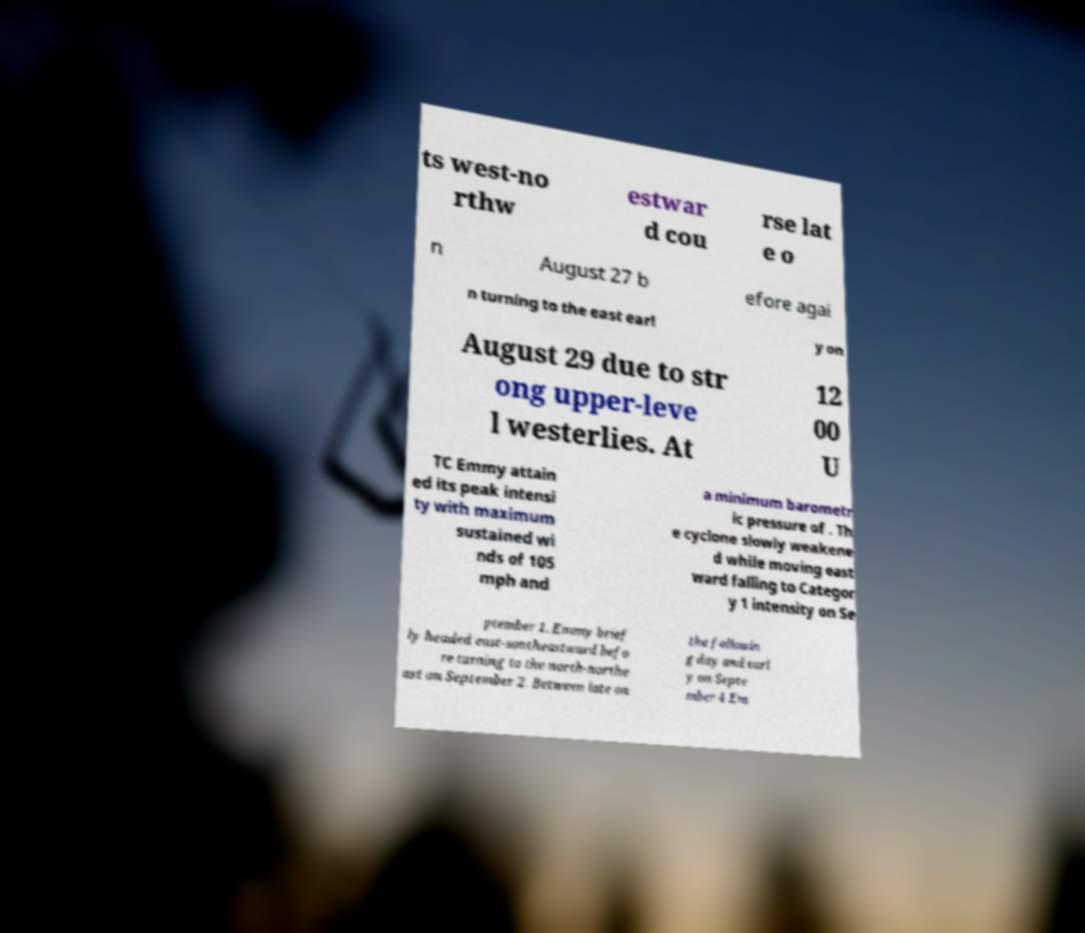Can you read and provide the text displayed in the image?This photo seems to have some interesting text. Can you extract and type it out for me? ts west-no rthw estwar d cou rse lat e o n August 27 b efore agai n turning to the east earl y on August 29 due to str ong upper-leve l westerlies. At 12 00 U TC Emmy attain ed its peak intensi ty with maximum sustained wi nds of 105 mph and a minimum barometr ic pressure of . Th e cyclone slowly weakene d while moving east ward falling to Categor y 1 intensity on Se ptember 1. Emmy brief ly headed east-southeastward befo re turning to the north-northe ast on September 2. Between late on the followin g day and earl y on Septe mber 4 Em 